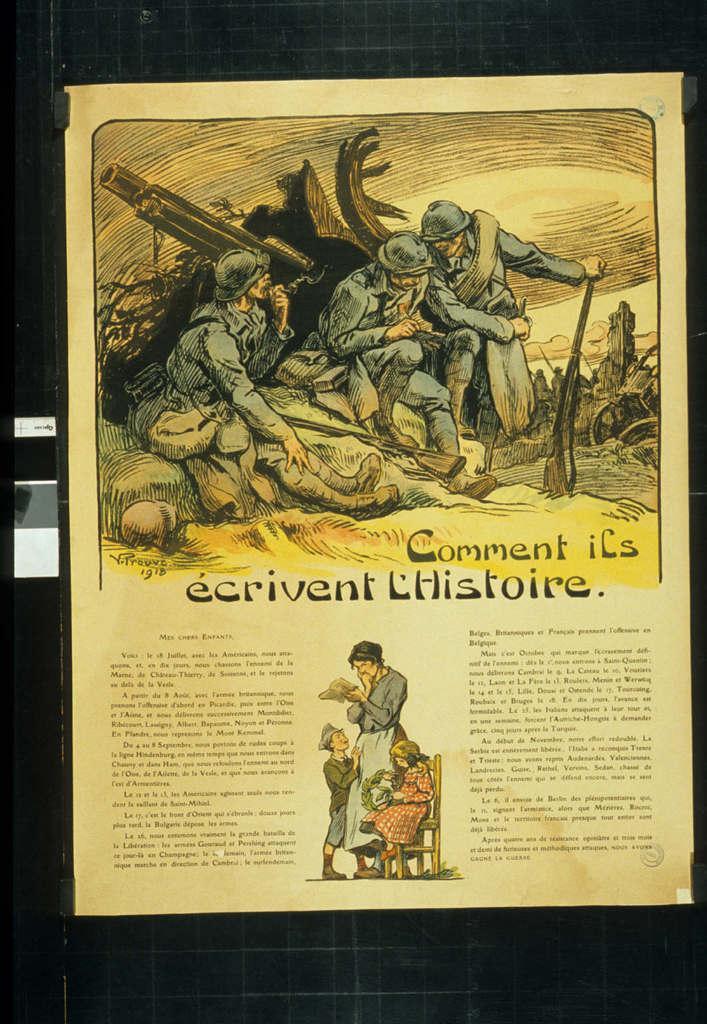In one or two sentences, can you explain what this image depicts? In this picture I can see a paper with some text and pictures. 